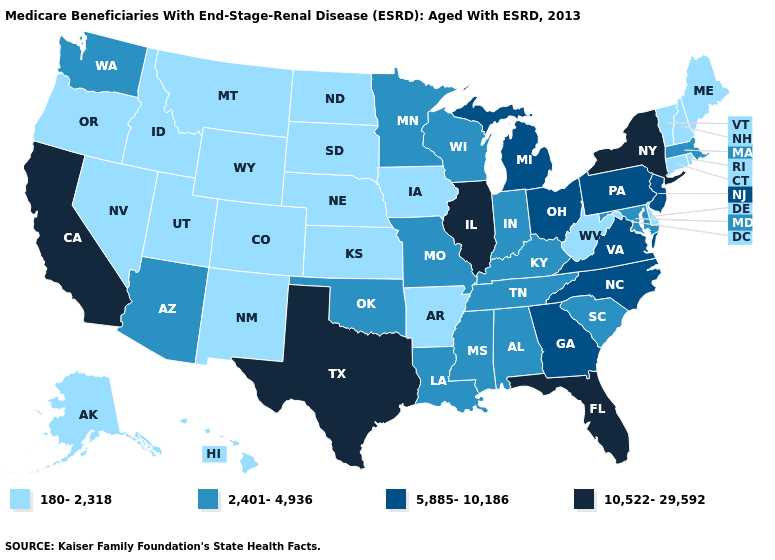Name the states that have a value in the range 2,401-4,936?
Short answer required. Alabama, Arizona, Indiana, Kentucky, Louisiana, Maryland, Massachusetts, Minnesota, Mississippi, Missouri, Oklahoma, South Carolina, Tennessee, Washington, Wisconsin. Does Colorado have the lowest value in the USA?
Quick response, please. Yes. Among the states that border Alabama , which have the highest value?
Be succinct. Florida. Name the states that have a value in the range 180-2,318?
Be succinct. Alaska, Arkansas, Colorado, Connecticut, Delaware, Hawaii, Idaho, Iowa, Kansas, Maine, Montana, Nebraska, Nevada, New Hampshire, New Mexico, North Dakota, Oregon, Rhode Island, South Dakota, Utah, Vermont, West Virginia, Wyoming. How many symbols are there in the legend?
Give a very brief answer. 4. Name the states that have a value in the range 10,522-29,592?
Keep it brief. California, Florida, Illinois, New York, Texas. What is the value of California?
Answer briefly. 10,522-29,592. Name the states that have a value in the range 5,885-10,186?
Short answer required. Georgia, Michigan, New Jersey, North Carolina, Ohio, Pennsylvania, Virginia. What is the value of New Mexico?
Concise answer only. 180-2,318. What is the lowest value in states that border Ohio?
Write a very short answer. 180-2,318. Does Arkansas have the lowest value in the South?
Quick response, please. Yes. What is the lowest value in the USA?
Quick response, please. 180-2,318. Does South Dakota have a higher value than Oklahoma?
Keep it brief. No. Does Iowa have a lower value than Georgia?
Short answer required. Yes. Name the states that have a value in the range 2,401-4,936?
Give a very brief answer. Alabama, Arizona, Indiana, Kentucky, Louisiana, Maryland, Massachusetts, Minnesota, Mississippi, Missouri, Oklahoma, South Carolina, Tennessee, Washington, Wisconsin. 